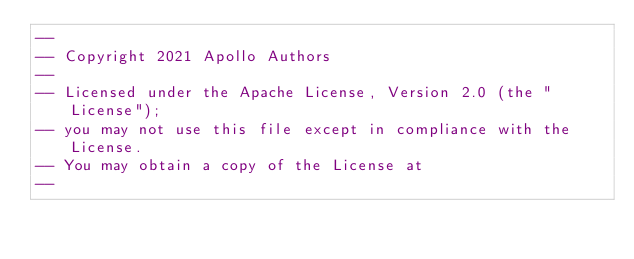Convert code to text. <code><loc_0><loc_0><loc_500><loc_500><_SQL_>--
-- Copyright 2021 Apollo Authors
--
-- Licensed under the Apache License, Version 2.0 (the "License");
-- you may not use this file except in compliance with the License.
-- You may obtain a copy of the License at
--</code> 